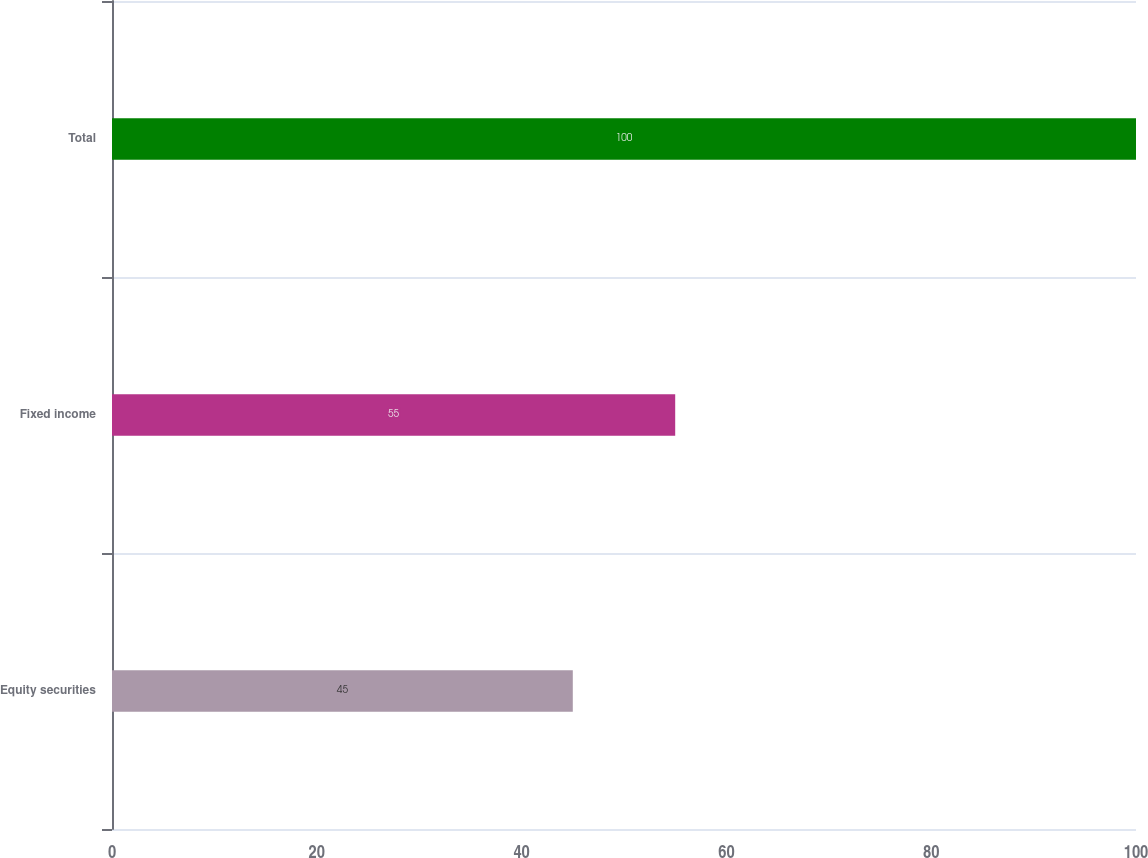Convert chart. <chart><loc_0><loc_0><loc_500><loc_500><bar_chart><fcel>Equity securities<fcel>Fixed income<fcel>Total<nl><fcel>45<fcel>55<fcel>100<nl></chart> 